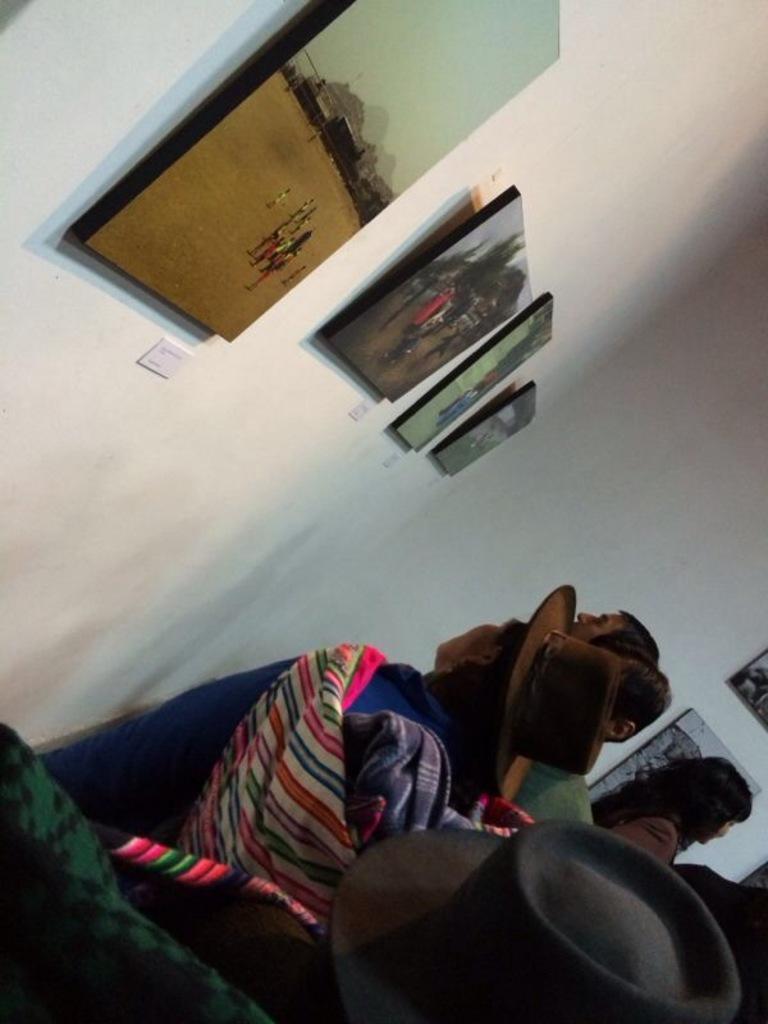Describe this image in one or two sentences. In this picture I can see some frames to the wall, in front some people are standing and watching. 